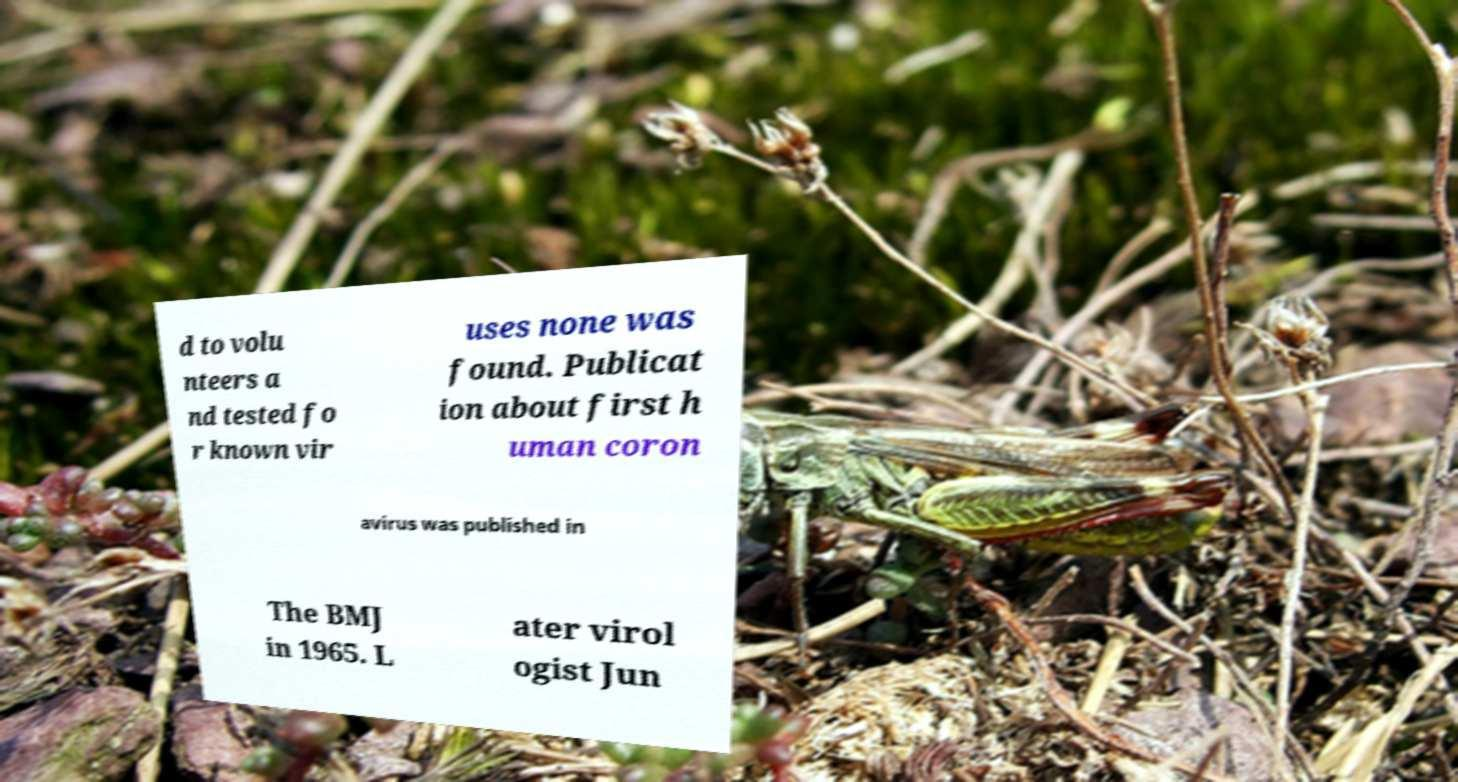For documentation purposes, I need the text within this image transcribed. Could you provide that? d to volu nteers a nd tested fo r known vir uses none was found. Publicat ion about first h uman coron avirus was published in The BMJ in 1965. L ater virol ogist Jun 